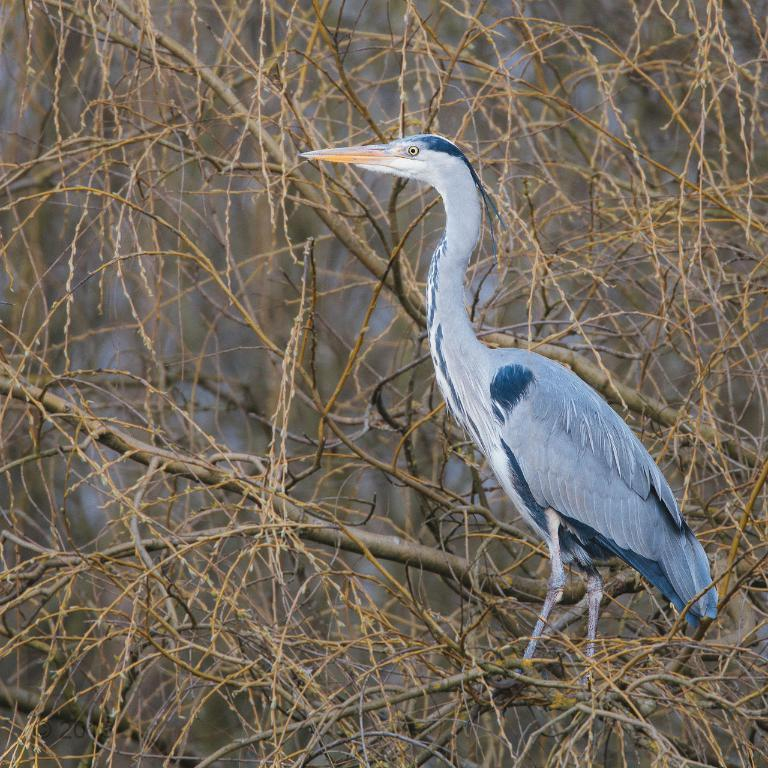What is the main subject of the image? There is a bird on a dried tree in the image. What type of vegetation is present in the image? There are dried trees in the image. Can you describe the background of the image? The background of the image is blurred. How many legs does the bird have in the image? The bird has two legs in the image. What type of adjustment can be seen in the image? There is no specific adjustment visible in the image. Can you describe any signs of an earthquake in the image? There are no signs of an earthquake present in the image. 